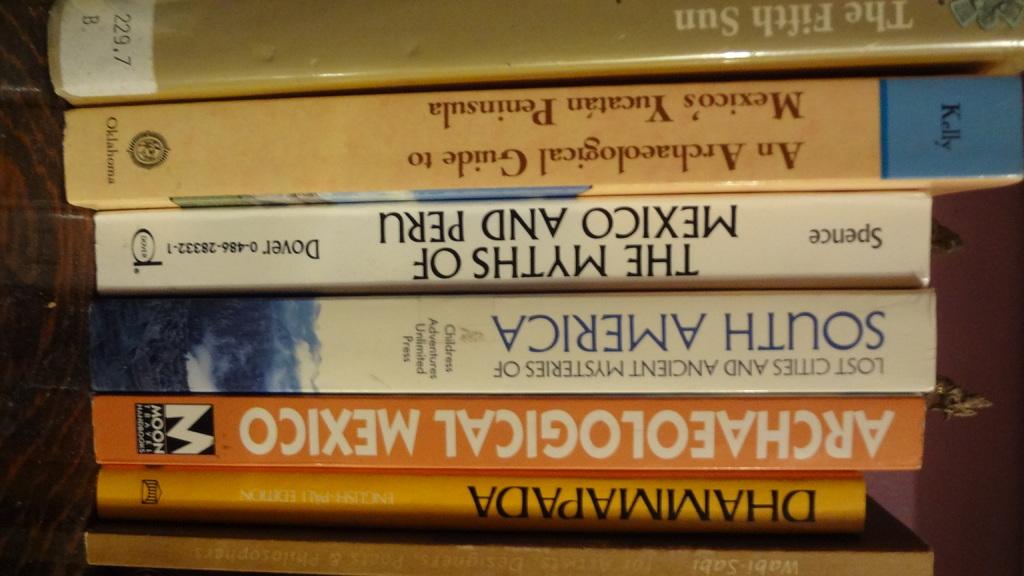Spence wrote a book on the myths of what two countries?
Keep it short and to the point. Mexico and peru. Which continent are the lost cities and ancient mysteries located?
Your answer should be compact. South america. 